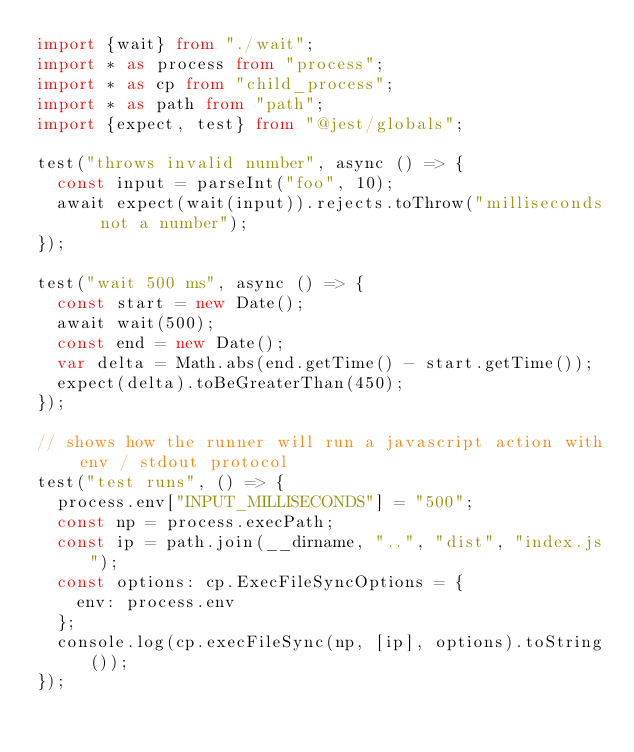<code> <loc_0><loc_0><loc_500><loc_500><_TypeScript_>import {wait} from "./wait";
import * as process from "process";
import * as cp from "child_process";
import * as path from "path";
import {expect, test} from "@jest/globals";

test("throws invalid number", async () => {
  const input = parseInt("foo", 10);
  await expect(wait(input)).rejects.toThrow("milliseconds not a number");
});

test("wait 500 ms", async () => {
  const start = new Date();
  await wait(500);
  const end = new Date();
  var delta = Math.abs(end.getTime() - start.getTime());
  expect(delta).toBeGreaterThan(450);
});

// shows how the runner will run a javascript action with env / stdout protocol
test("test runs", () => {
  process.env["INPUT_MILLISECONDS"] = "500";
  const np = process.execPath;
  const ip = path.join(__dirname, "..", "dist", "index.js");
  const options: cp.ExecFileSyncOptions = {
    env: process.env
  };
  console.log(cp.execFileSync(np, [ip], options).toString());
});
</code> 